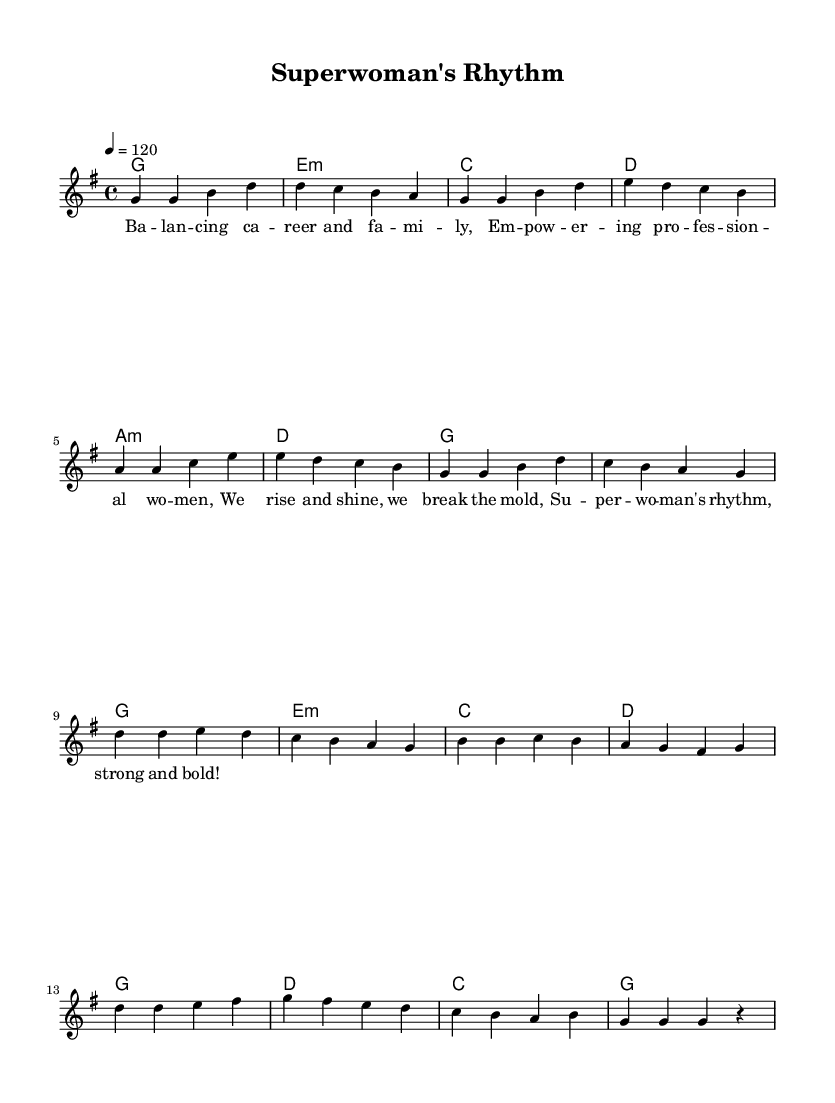What is the key signature of this music? The key signature is G major, which has one sharp (F#).
Answer: G major What is the time signature of this music? The time signature is 4/4, meaning there are four beats per measure and the quarter note receives one beat.
Answer: 4/4 What is the tempo marking? The tempo marking indicates a speed of 120 beats per minute, reflecting the pace at which the music should be performed.
Answer: 120 How many measures are in the verse section? The verse contains eight measures, as indicated by the sequence of the melodic and harmonic lines.
Answer: Eight What is the primary theme of the lyrics? The lyrics focus on empowering professional women who balance their careers and families, which is a central theme in the style of K-Pop anthems.
Answer: Empowerment What type of chord progression starts the chorus? The chorus starts with a G major chord, which is the tonic in the key of G major, providing a strong resolution and emphasis.
Answer: G major Does this song structure include repetition? Yes, the structure includes repetition, especially in the verse and chorus, which is a common feature in K-Pop for memorability and catchiness.
Answer: Yes 